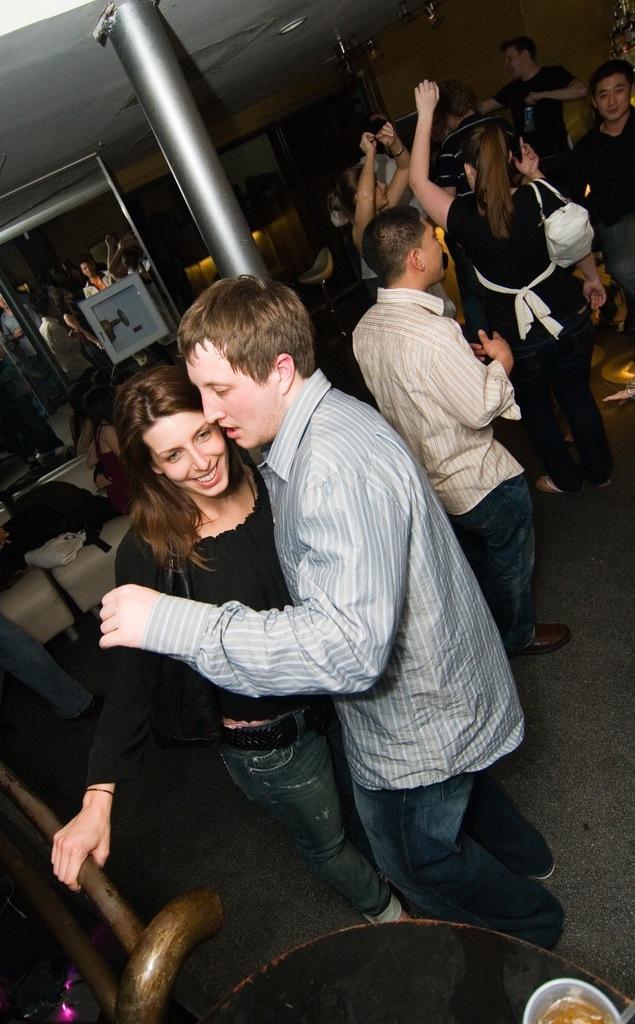Describe this image in one or two sentences. These people are dancing. On this couch there are things. This is pillar. 